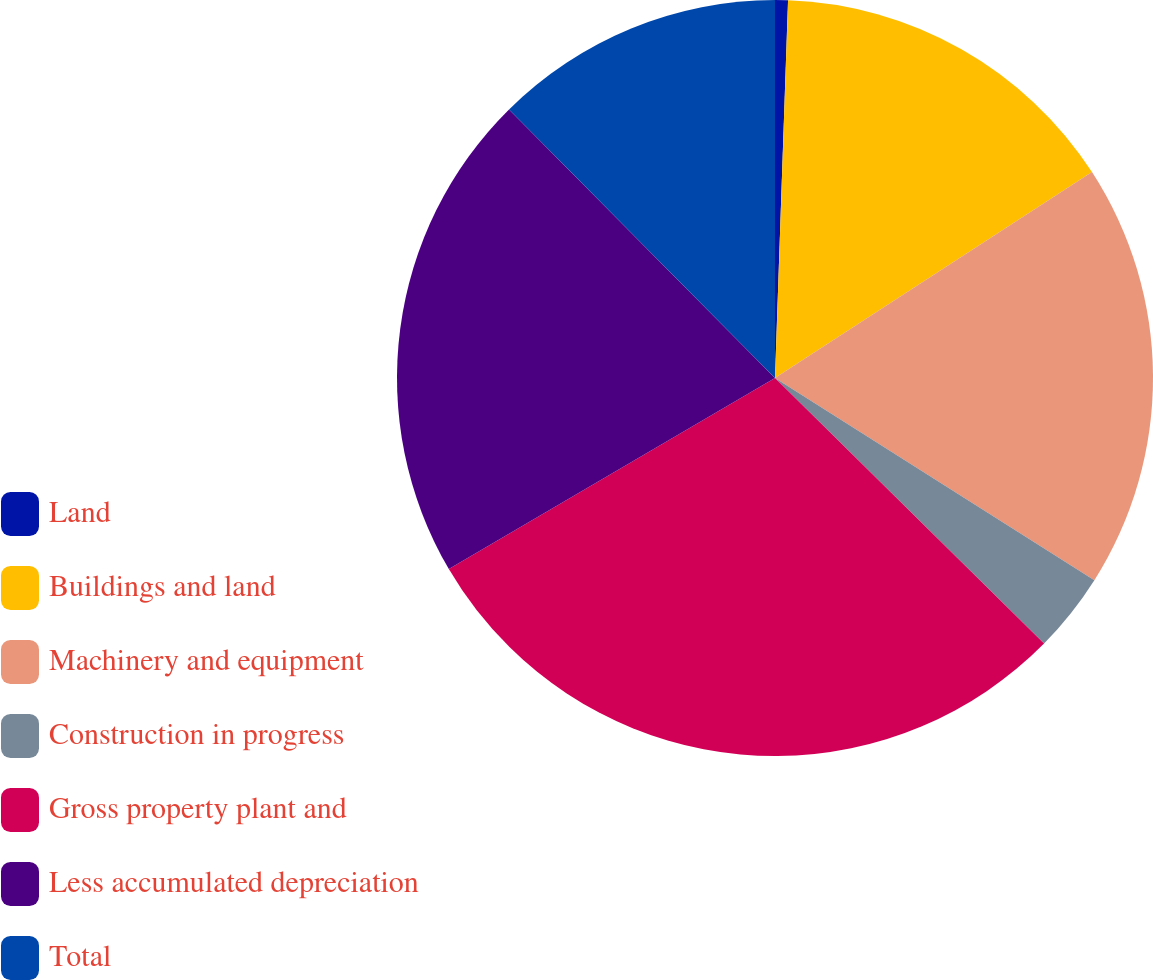Convert chart. <chart><loc_0><loc_0><loc_500><loc_500><pie_chart><fcel>Land<fcel>Buildings and land<fcel>Machinery and equipment<fcel>Construction in progress<fcel>Gross property plant and<fcel>Less accumulated depreciation<fcel>Total<nl><fcel>0.55%<fcel>15.28%<fcel>18.15%<fcel>3.41%<fcel>29.17%<fcel>21.01%<fcel>12.42%<nl></chart> 